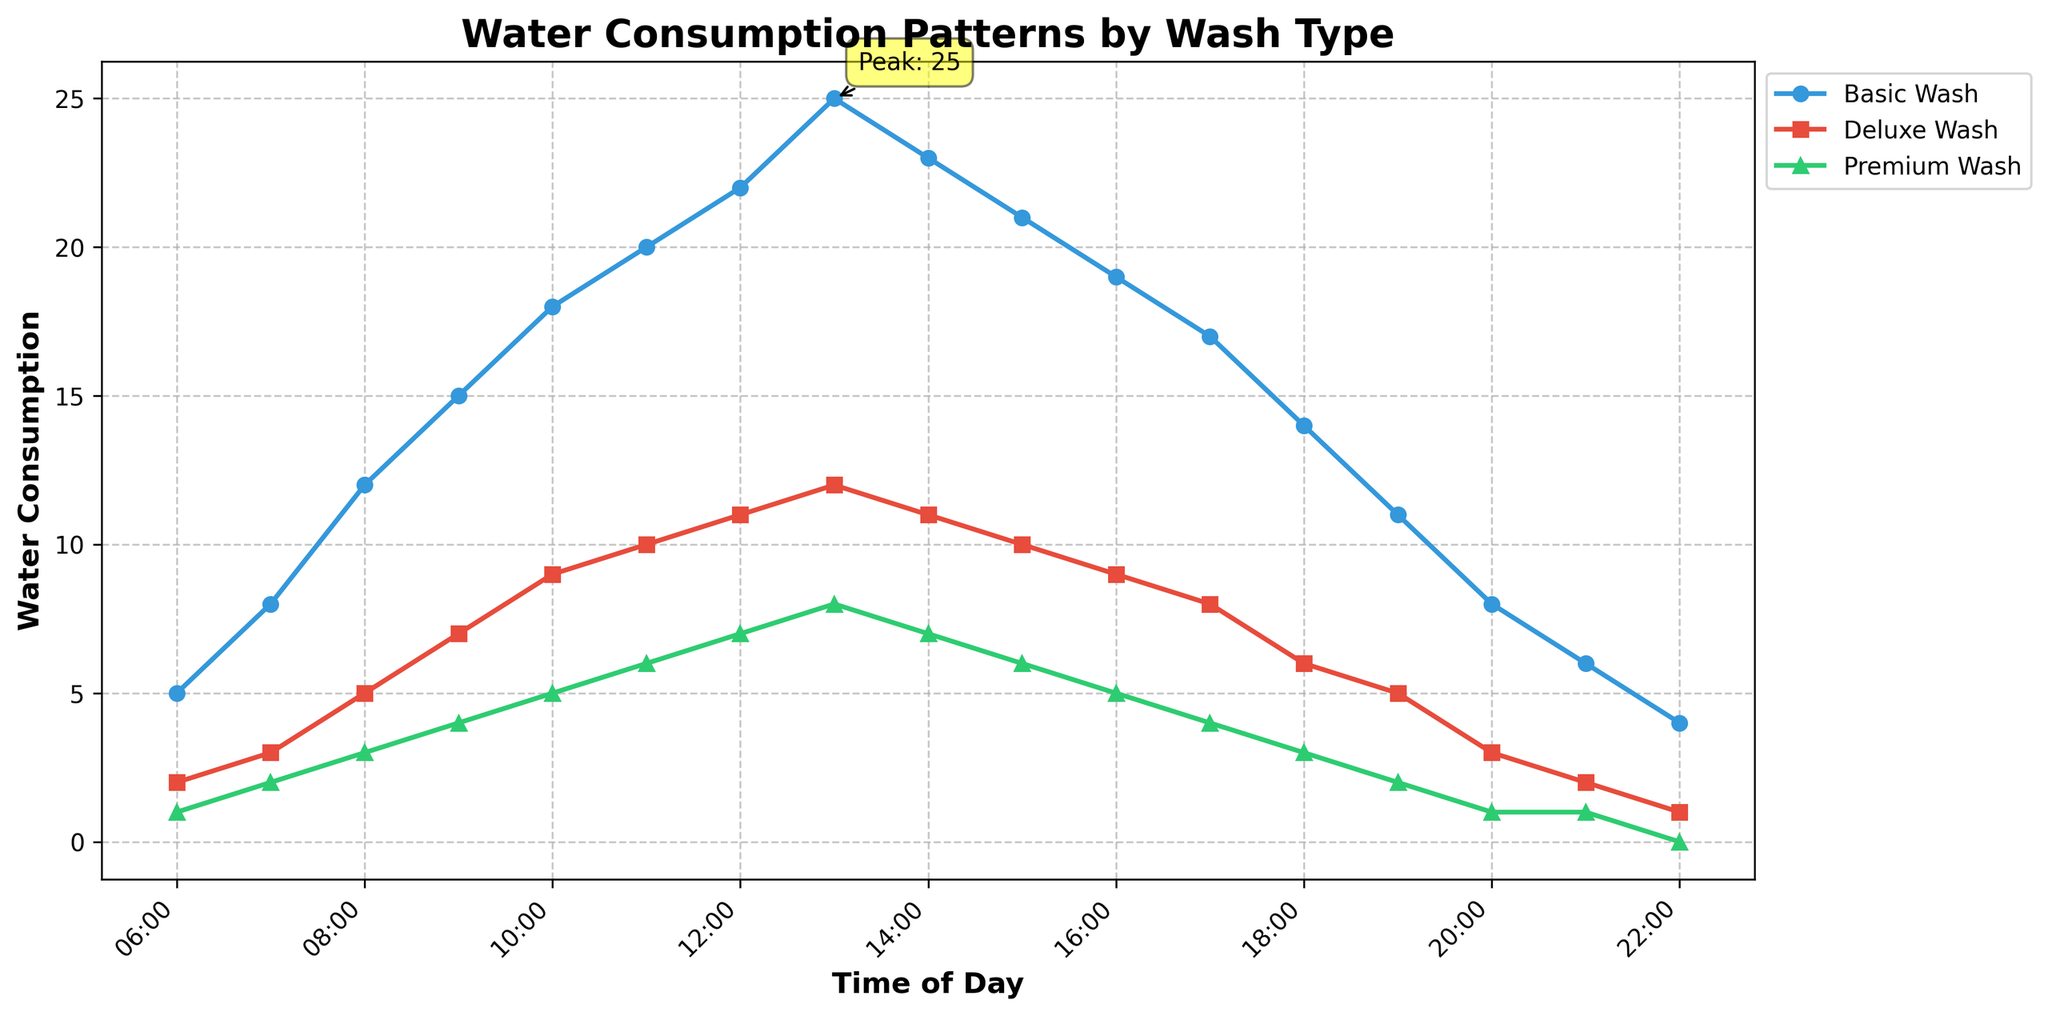What time does the Basic Wash peak in water consumption? The peak water consumption for Basic Wash is the highest value on the blue line. From the plot, it reaches its peak at 13:00.
Answer: 13:00 In the evening hours, which wash type consistently consumes the least water? In the evening hours (18:00 onwards), the green line, representing Premium Wash, is consistently lower than the other lines.
Answer: Premium Wash How does the water consumption pattern of Deluxe Wash between 6:00 and 9:00 compare to that of Basic Wash in the same period? From 6:00 to 9:00, the red line (Deluxe Wash) is consistently lower than the blue line (Basic Wash). For instance, at 6:00, Deluxe Wash is at 2 while Basic Wash is at 5.
Answer: Deluxe Wash is lower What is the total water consumption for Deluxe Wash and Premium Wash combined at 12:00? At 12:00, the Deluxe Wash (red) consumes 11 units and the Premium Wash (green) consumes 7 units. Adding them gives 11 + 7.
Answer: 18 units During which hours do all three wash types exhibit a declining trend in water consumption? Observing the plot, all three lines (blue, red, green) show a declining trend post 14:00 up to the end of the day at 22:00.
Answer: 14:00 onwards Compare the water consumption at 10:00 between Basic Wash and Premium Wash. At 10:00, the blue line (Basic Wash) is at 18 units, and the green line (Premium Wash) is at 5 units.
Answer: Basic Wash is higher Identify the time slot where Basic Wash and Deluxe Wash have the same water consumption. By observing the plot, at 21:00, both the blue line (Basic Wash) and the red line (Deluxe Wash) are at 6 and 2 respectively, which are the closest the lines come to each other but not equal.
Answer: No exact match found Which wash type shows the most variation in water consumption throughout the day? By looking at the range of the y-values for each line, the blue line (Basic Wash) shows the most variation, ranging from 4 to 25 units.
Answer: Basic Wash What is the difference in water consumption between Basic Wash and Deluxe Wash at their respective peaks? The peak for Basic Wash is 25 units at 13:00, and for Deluxe Wash is 12 units at 13:00. The difference is 25 - 12.
Answer: 13 units 